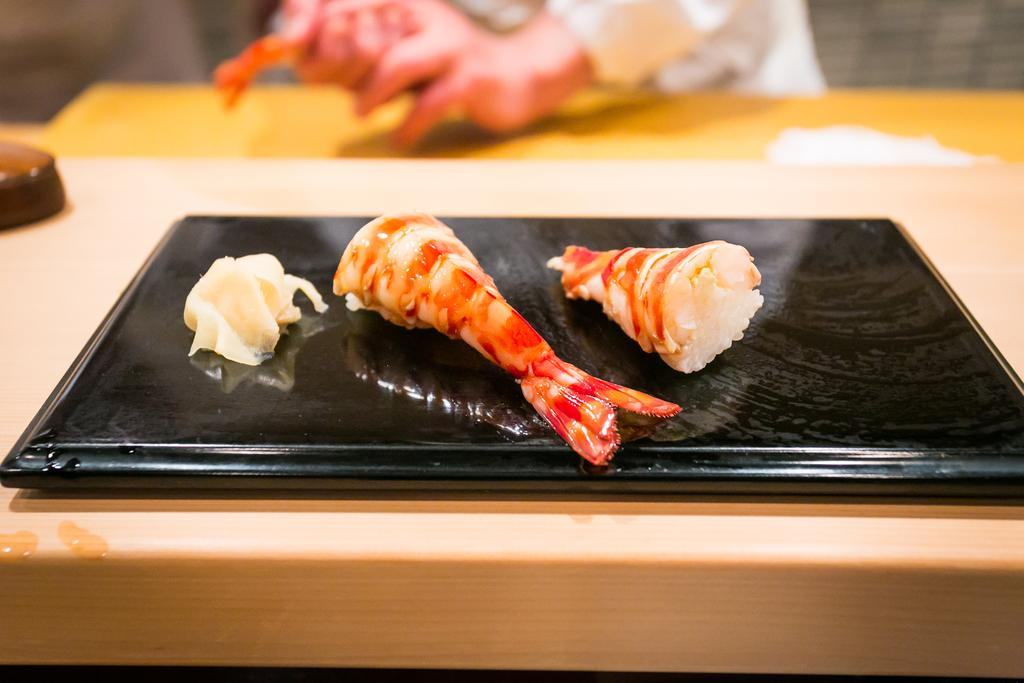What type of food is visible in the image? There is meat in the image. What is the meat placed on or in? The meat is on an object. Can you describe the background of the image? The background of the image is blurry. What type of kettle is visible in the image? There is no kettle present in the image. Can you describe the artistic style of the meat in the image? The image does not depict the meat in an artistic style; it is a straightforward representation of the food. 